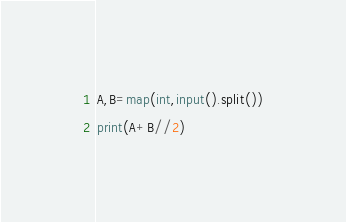Convert code to text. <code><loc_0><loc_0><loc_500><loc_500><_Python_>A,B=map(int,input().split())
print(A+B//2)</code> 